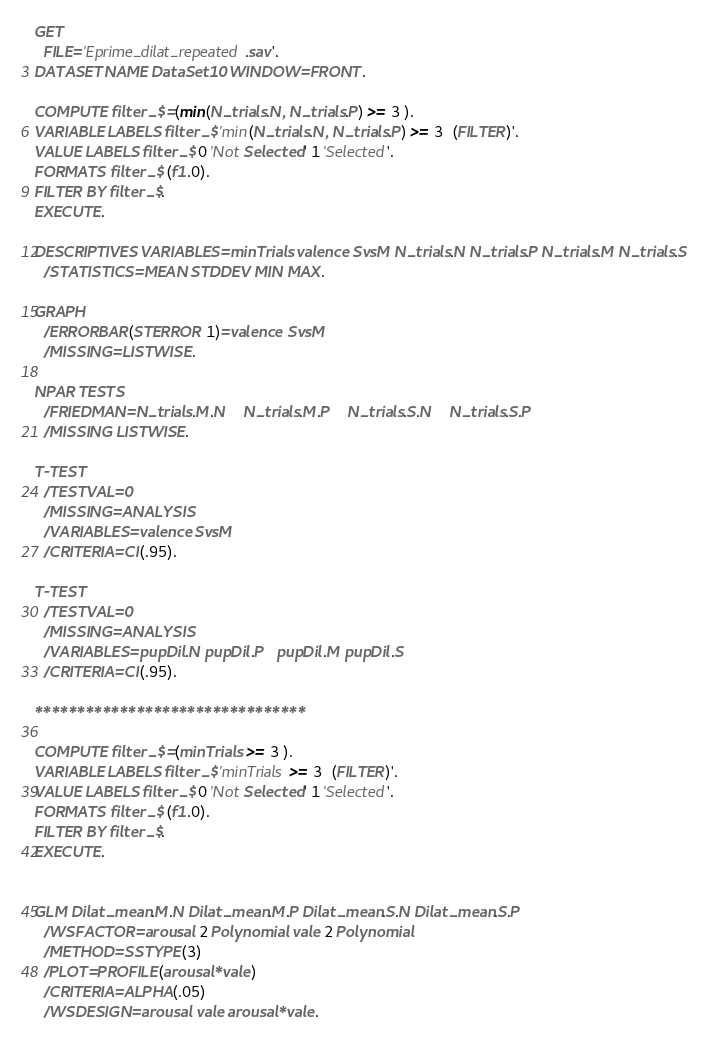<code> <loc_0><loc_0><loc_500><loc_500><_Scheme_>GET
  FILE='Eprime_dilat_repeated.sav'.
DATASET NAME DataSet10 WINDOW=FRONT.

COMPUTE filter_$=(min(N_trials.N, N_trials.P) >= 3 ). 
VARIABLE LABELS filter_$ 'min(N_trials.N, N_trials.P) >= 3  (FILTER)'. 
VALUE LABELS filter_$ 0 'Not Selected' 1 'Selected'. 
FORMATS filter_$ (f1.0). 
FILTER BY filter_$. 
EXECUTE.
  
DESCRIPTIVES VARIABLES=minTrials valence SvsM N_trials.N N_trials.P N_trials.M N_trials.S
  /STATISTICS=MEAN STDDEV MIN MAX.

GRAPH 
  /ERRORBAR(STERROR 1)=valence SvsM
  /MISSING=LISTWISE.

NPAR TESTS 
  /FRIEDMAN=N_trials.M.N    N_trials.M.P    N_trials.S.N    N_trials.S.P
  /MISSING LISTWISE.

T-TEST 
  /TESTVAL=0 
  /MISSING=ANALYSIS 
  /VARIABLES=valence SvsM  
  /CRITERIA=CI(.95).

T-TEST 
  /TESTVAL=0 
  /MISSING=ANALYSIS 
  /VARIABLES=pupDil.N pupDil.P   pupDil.M pupDil.S   
  /CRITERIA=CI(.95).

********************************

COMPUTE filter_$=(minTrials >= 3 ). 
VARIABLE LABELS filter_$ 'minTrials >= 3  (FILTER)'. 
VALUE LABELS filter_$ 0 'Not Selected' 1 'Selected'. 
FORMATS filter_$ (f1.0). 
FILTER BY filter_$. 
EXECUTE.

 
GLM Dilat_mean.M.N Dilat_mean.M.P Dilat_mean.S.N Dilat_mean.S.P 
  /WSFACTOR=arousal 2 Polynomial vale 2 Polynomial 
  /METHOD=SSTYPE(3) 
  /PLOT=PROFILE(arousal*vale) 
  /CRITERIA=ALPHA(.05) 
  /WSDESIGN=arousal vale arousal*vale.





</code> 